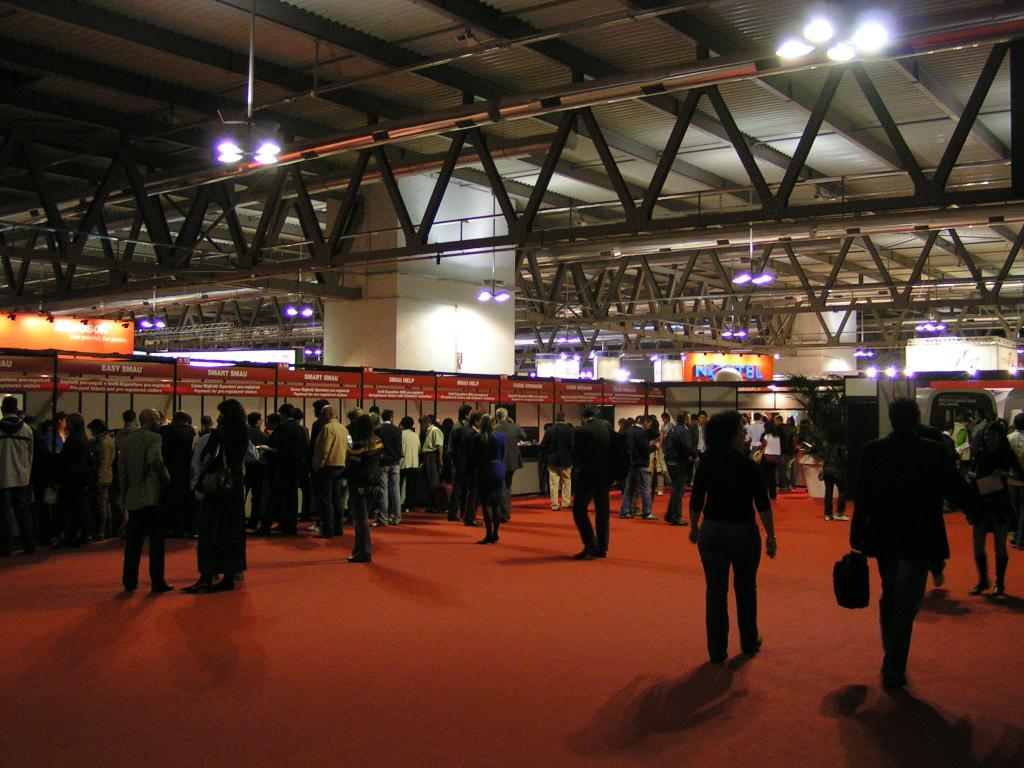What is happening with the group of people in the image? There is a group of people standing in the image, and some people are walking. What can be seen in the background of the image? In the background of the image, there are lights, posters, a pillar, a roof, and some objects. Can you describe the setting of the image? The image appears to be set in an outdoor or semi-enclosed area with a roof and pillar, and there are lights and posters in the background. What type of window can be seen in the image? There is no window present in the image. 